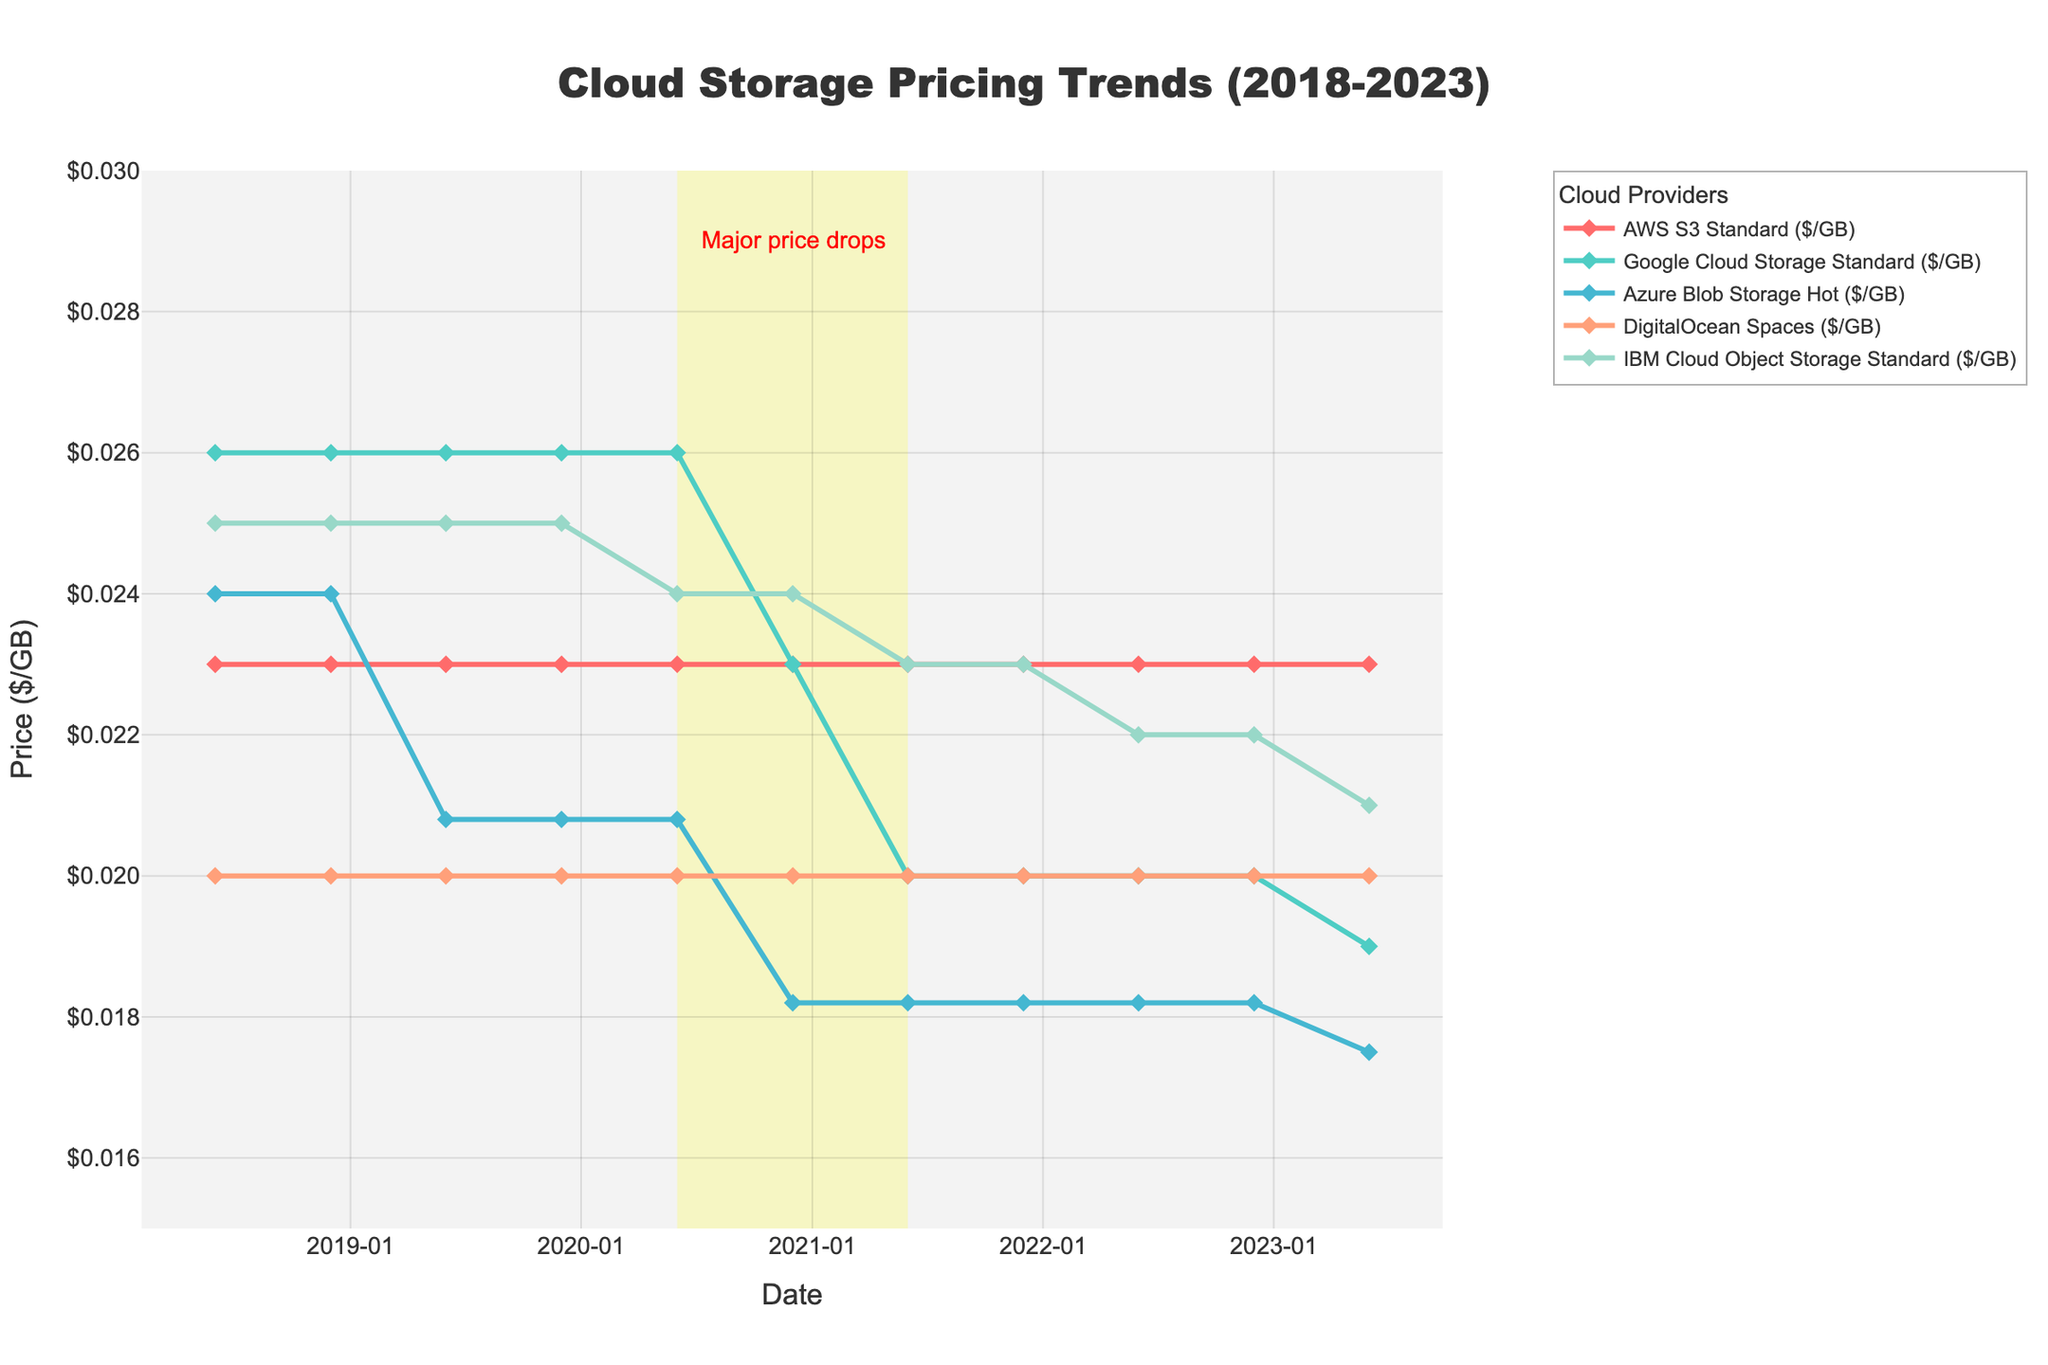What is the trend observed in AWS S3 Standard pricing over the last 5 years? The AWS S3 Standard pricing has remained constant at $0.023/GB throughout the last 5 years. This can be observed from the consistent line at $0.023 from 2018 to 2023.
Answer: Remained constant Which provider had the highest price in June 2023? In June 2023, AWS S3 Standard had a price of $0.023/GB, which is higher than Google Cloud Storage ($0.019), Azure Blob Storage ($0.0175), DigitalOcean Spaces ($0.02), and IBM Cloud Object Storage ($0.021).
Answer: AWS S3 Standard Which provider showed the most significant price drop between December 2019 and June 2023? Azure Blob Storage Hot reduced its price from $0.0208/GB in December 2019 to $0.0175/GB in June 2023, indicating a significant decrease.
Answer: Azure Blob Storage Hot Between which time periods did we observe the major price drops highlighted in the plot? The yellow rectangular highlight on the plot marks the period between June 2020 and June 2021, indicating that major price drops occurred in this timeframe.
Answer: June 2020 to June 2021 What is the price difference between Google Cloud Storage and Azure Blob Storage in December 2020? In December 2020, Google Cloud Storage had a price of $0.023/GB, and Azure Blob Storage had a price of $0.0182/GB. The difference is $0.023 - $0.0182 = $0.0048.
Answer: $0.0048 How did IBM Cloud Object Storage pricing change from June 2020 to June 2023? IBM Cloud Object Storage pricing changed from $0.024/GB in June 2020 to $0.021/GB in June 2023.
Answer: Decreased by $0.003 Which provider was consistently the cheapest from June 2018 to June 2023? DigitalOcean Spaces consistently had the lowest price of $0.02/GB from June 2018 to June 2023.
Answer: DigitalOcean Spaces What is the difference between the highest and lowest prices in December 2021? In December 2021, AWS S3 Standard was the highest at $0.023/GB, and Azure Blob Storage Hot was the lowest at $0.0182/GB. The difference is $0.023 - $0.0182 = $0.0048/GB.
Answer: $0.0048/GB 